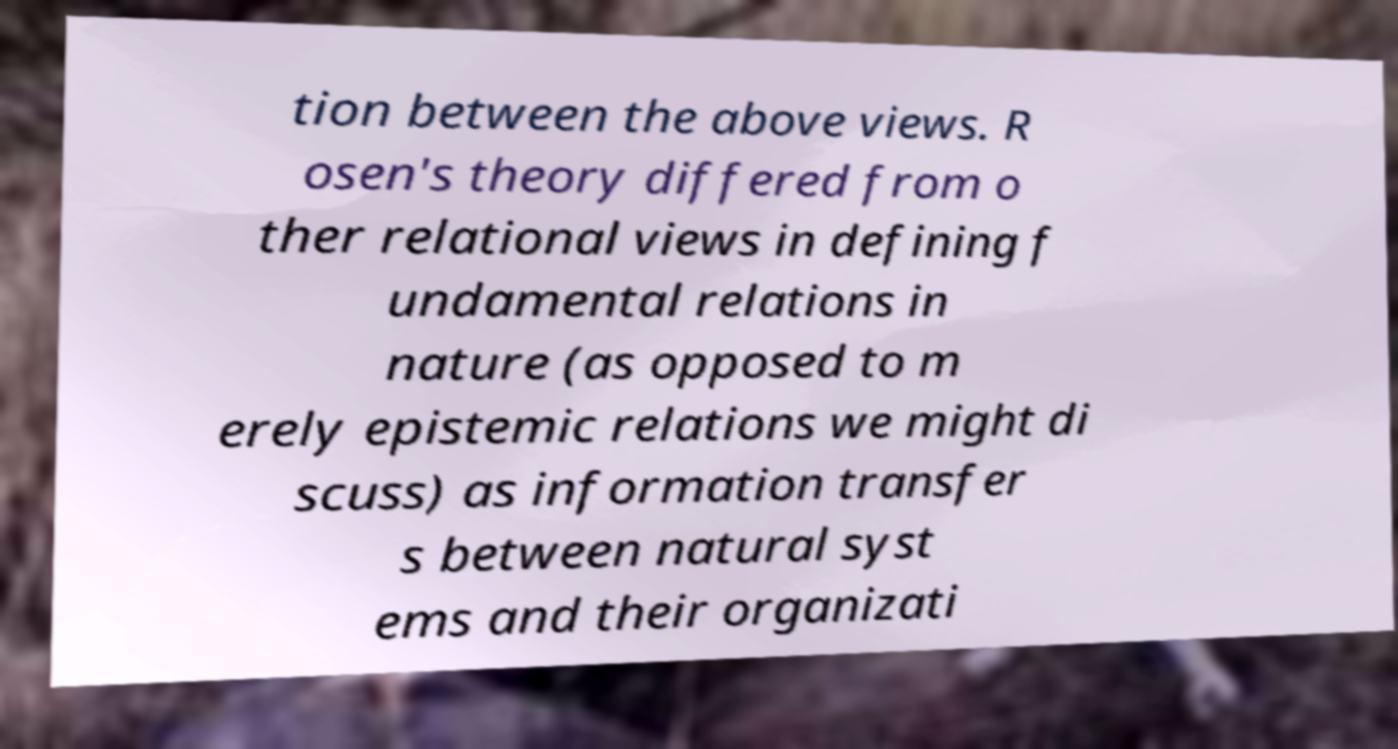For documentation purposes, I need the text within this image transcribed. Could you provide that? tion between the above views. R osen's theory differed from o ther relational views in defining f undamental relations in nature (as opposed to m erely epistemic relations we might di scuss) as information transfer s between natural syst ems and their organizati 